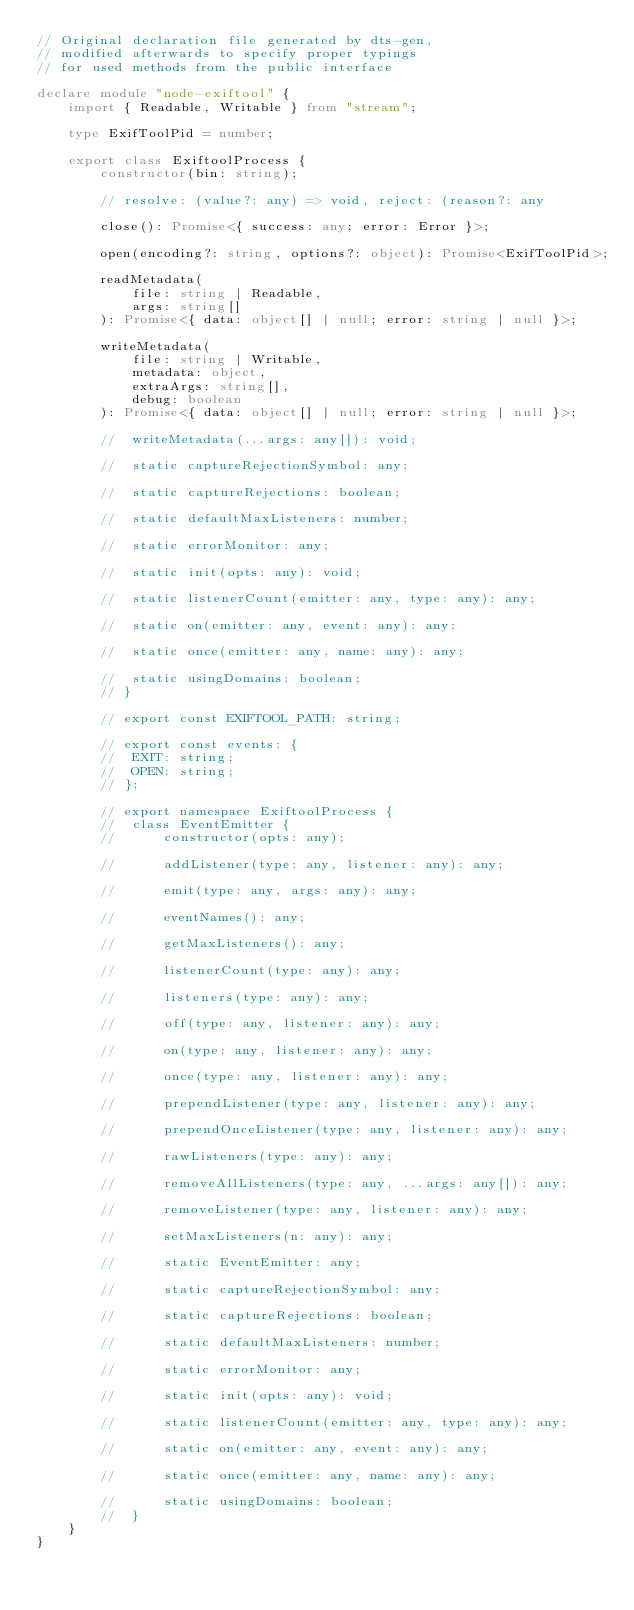<code> <loc_0><loc_0><loc_500><loc_500><_TypeScript_>// Original declaration file generated by dts-gen,
// modified afterwards to specify proper typings
// for used methods from the public interface

declare module "node-exiftool" {
	import { Readable, Writable } from "stream";

	type ExifToolPid = number;

	export class ExiftoolProcess {
		constructor(bin: string);

		// resolve: (value?: any) => void, reject: (reason?: any

		close(): Promise<{ success: any; error: Error }>;

		open(encoding?: string, options?: object): Promise<ExifToolPid>;

		readMetadata(
			file: string | Readable,
			args: string[]
		): Promise<{ data: object[] | null; error: string | null }>;

		writeMetadata(
			file: string | Writable,
			metadata: object,
			extraArgs: string[],
			debug: boolean
		): Promise<{ data: object[] | null; error: string | null }>;

		// 	writeMetadata(...args: any[]): void;

		// 	static captureRejectionSymbol: any;

		// 	static captureRejections: boolean;

		// 	static defaultMaxListeners: number;

		// 	static errorMonitor: any;

		// 	static init(opts: any): void;

		// 	static listenerCount(emitter: any, type: any): any;

		// 	static on(emitter: any, event: any): any;

		// 	static once(emitter: any, name: any): any;

		// 	static usingDomains: boolean;
		// }

		// export const EXIFTOOL_PATH: string;

		// export const events: {
		// 	EXIT: string;
		// 	OPEN: string;
		// };

		// export namespace ExiftoolProcess {
		// 	class EventEmitter {
		// 		constructor(opts: any);

		// 		addListener(type: any, listener: any): any;

		// 		emit(type: any, args: any): any;

		// 		eventNames(): any;

		// 		getMaxListeners(): any;

		// 		listenerCount(type: any): any;

		// 		listeners(type: any): any;

		// 		off(type: any, listener: any): any;

		// 		on(type: any, listener: any): any;

		// 		once(type: any, listener: any): any;

		// 		prependListener(type: any, listener: any): any;

		// 		prependOnceListener(type: any, listener: any): any;

		// 		rawListeners(type: any): any;

		// 		removeAllListeners(type: any, ...args: any[]): any;

		// 		removeListener(type: any, listener: any): any;

		// 		setMaxListeners(n: any): any;

		// 		static EventEmitter: any;

		// 		static captureRejectionSymbol: any;

		// 		static captureRejections: boolean;

		// 		static defaultMaxListeners: number;

		// 		static errorMonitor: any;

		// 		static init(opts: any): void;

		// 		static listenerCount(emitter: any, type: any): any;

		// 		static on(emitter: any, event: any): any;

		// 		static once(emitter: any, name: any): any;

		// 		static usingDomains: boolean;
		// 	}
	}
}
</code> 